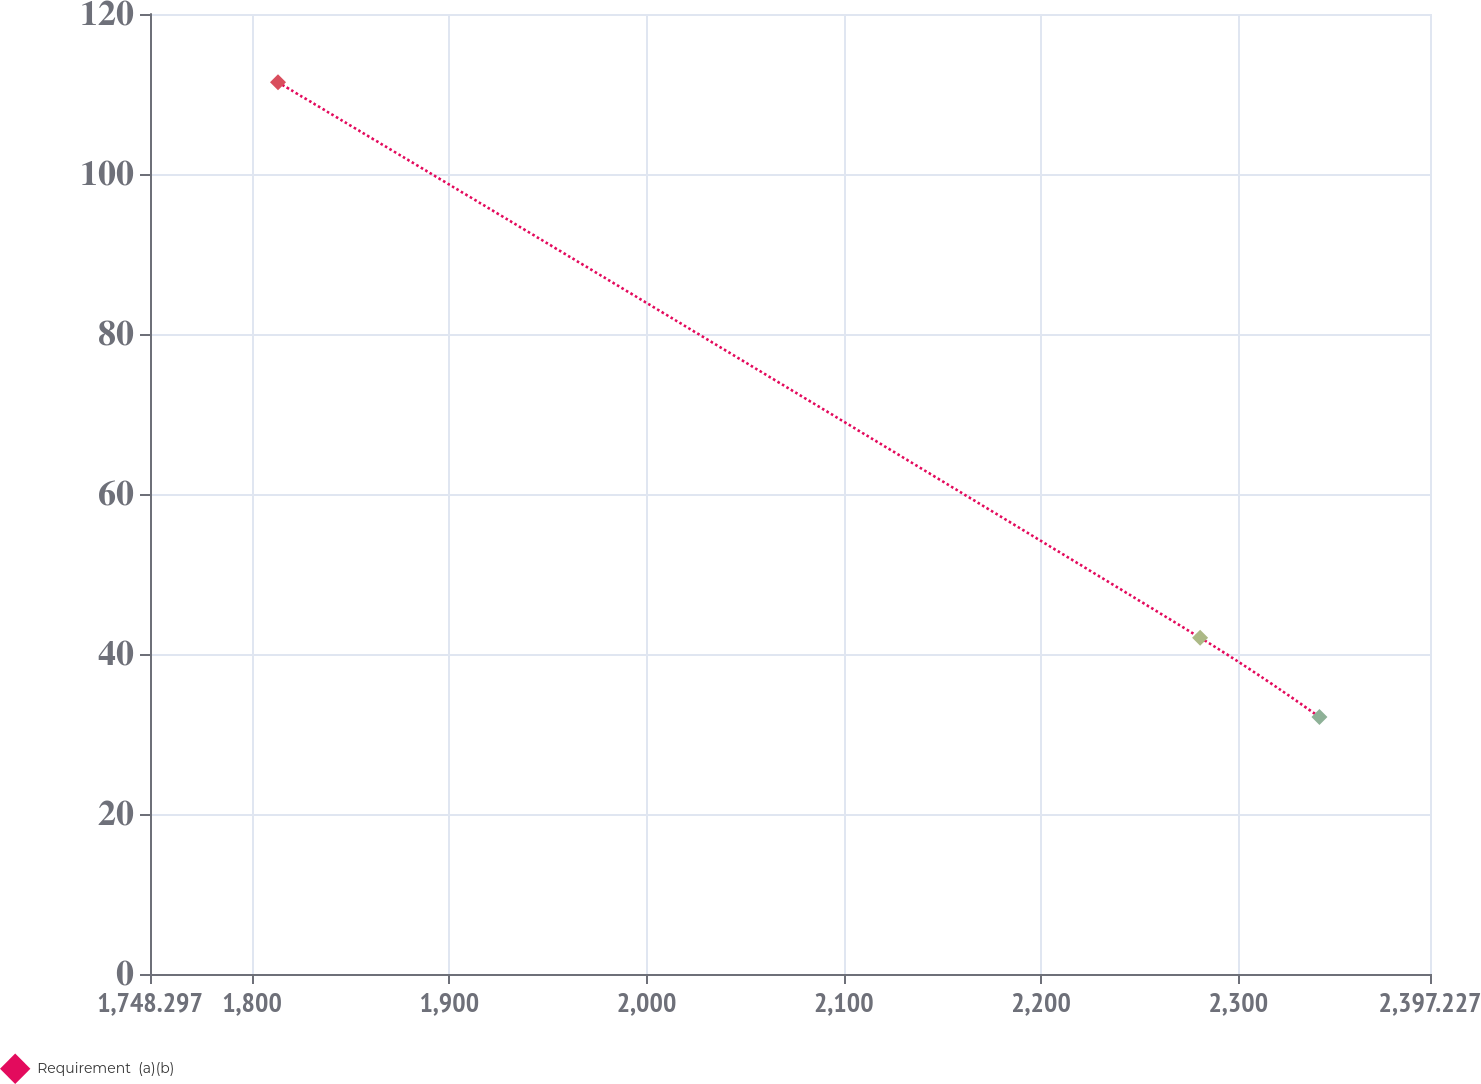Convert chart. <chart><loc_0><loc_0><loc_500><loc_500><line_chart><ecel><fcel>Requirement  (a)(b)<nl><fcel>1813.19<fcel>111.46<nl><fcel>2280.68<fcel>42.04<nl><fcel>2341.16<fcel>32.12<nl><fcel>2401.64<fcel>12.28<nl><fcel>2462.12<fcel>22.2<nl></chart> 